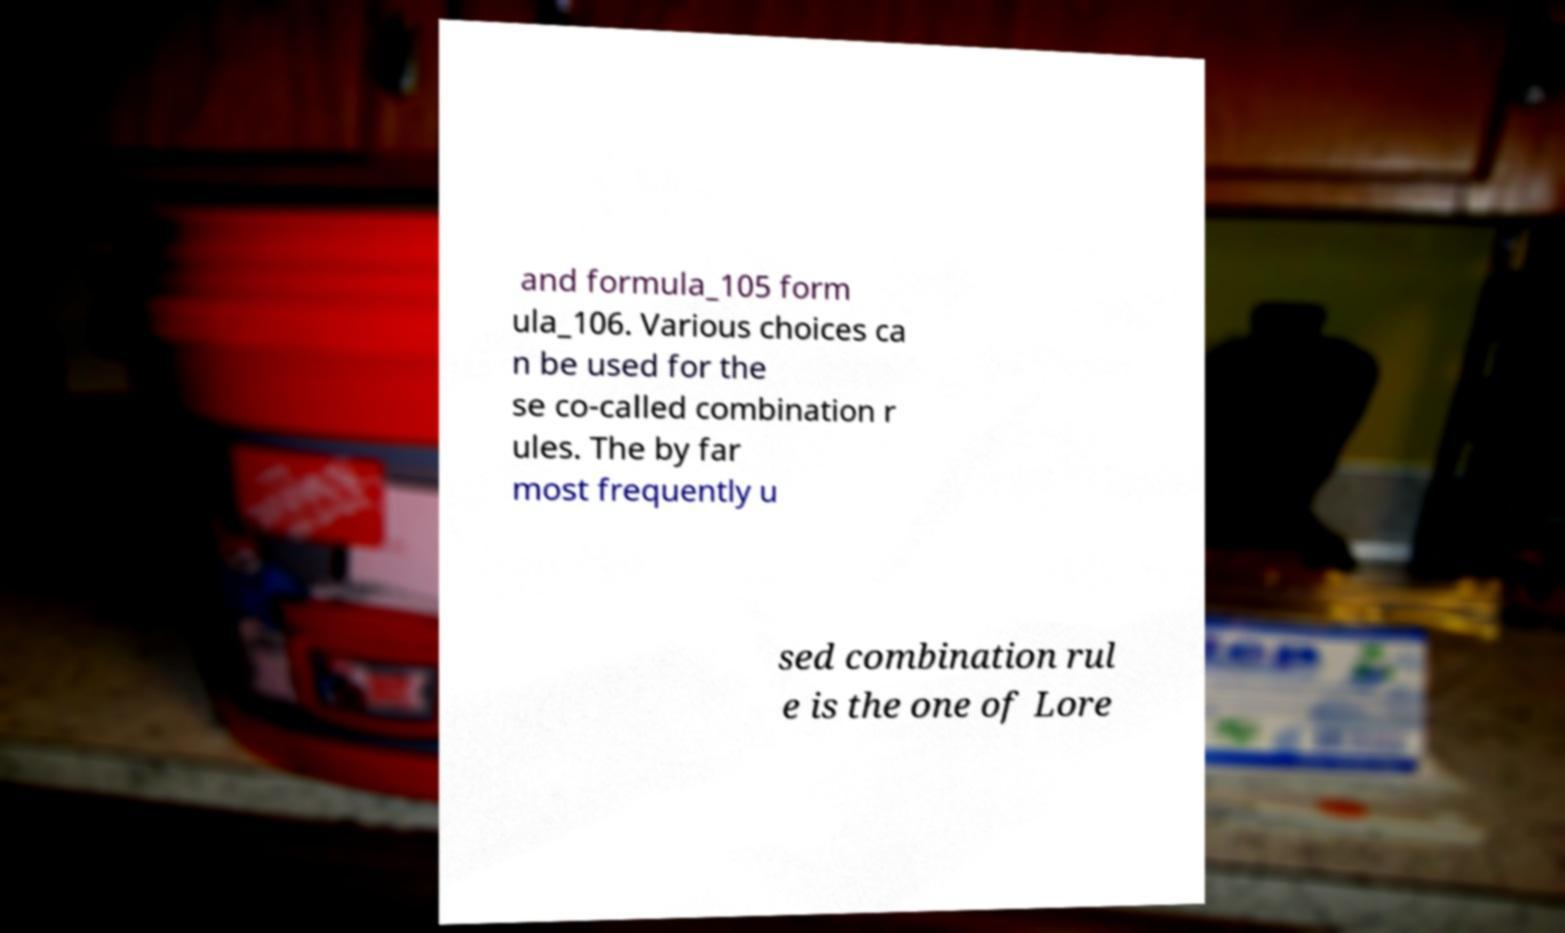Please read and relay the text visible in this image. What does it say? and formula_105 form ula_106. Various choices ca n be used for the se co-called combination r ules. The by far most frequently u sed combination rul e is the one of Lore 